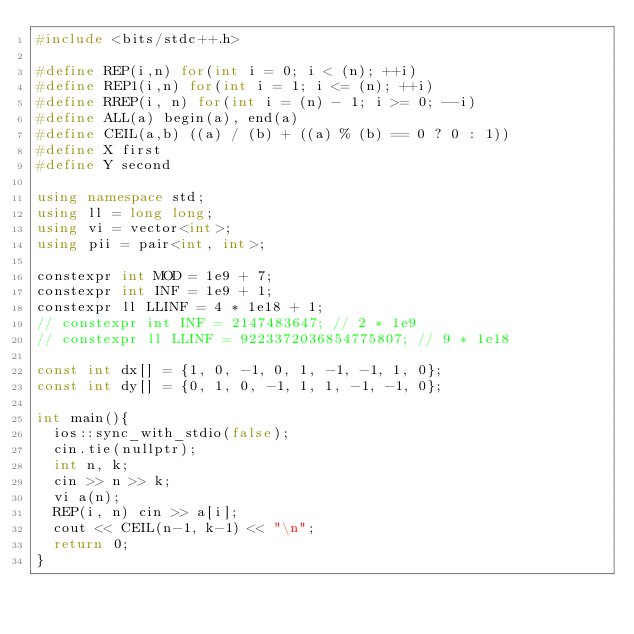Convert code to text. <code><loc_0><loc_0><loc_500><loc_500><_C++_>#include <bits/stdc++.h>

#define REP(i,n) for(int i = 0; i < (n); ++i)
#define REP1(i,n) for(int i = 1; i <= (n); ++i)
#define RREP(i, n) for(int i = (n) - 1; i >= 0; --i)
#define ALL(a) begin(a), end(a)
#define CEIL(a,b) ((a) / (b) + ((a) % (b) == 0 ? 0 : 1))
#define X first
#define Y second

using namespace std;
using ll = long long;
using vi = vector<int>;
using pii = pair<int, int>;

constexpr int MOD = 1e9 + 7;
constexpr int INF = 1e9 + 1;
constexpr ll LLINF = 4 * 1e18 + 1;
// constexpr int INF = 2147483647; // 2 * 1e9
// constexpr ll LLINF = 9223372036854775807; // 9 * 1e18

const int dx[] = {1, 0, -1, 0, 1, -1, -1, 1, 0};
const int dy[] = {0, 1, 0, -1, 1, 1, -1, -1, 0};

int main(){
	ios::sync_with_stdio(false);
	cin.tie(nullptr);
	int n, k;
	cin >> n >> k;
	vi a(n);
	REP(i, n) cin >> a[i];
	cout << CEIL(n-1, k-1) << "\n";
	return 0;
}
</code> 